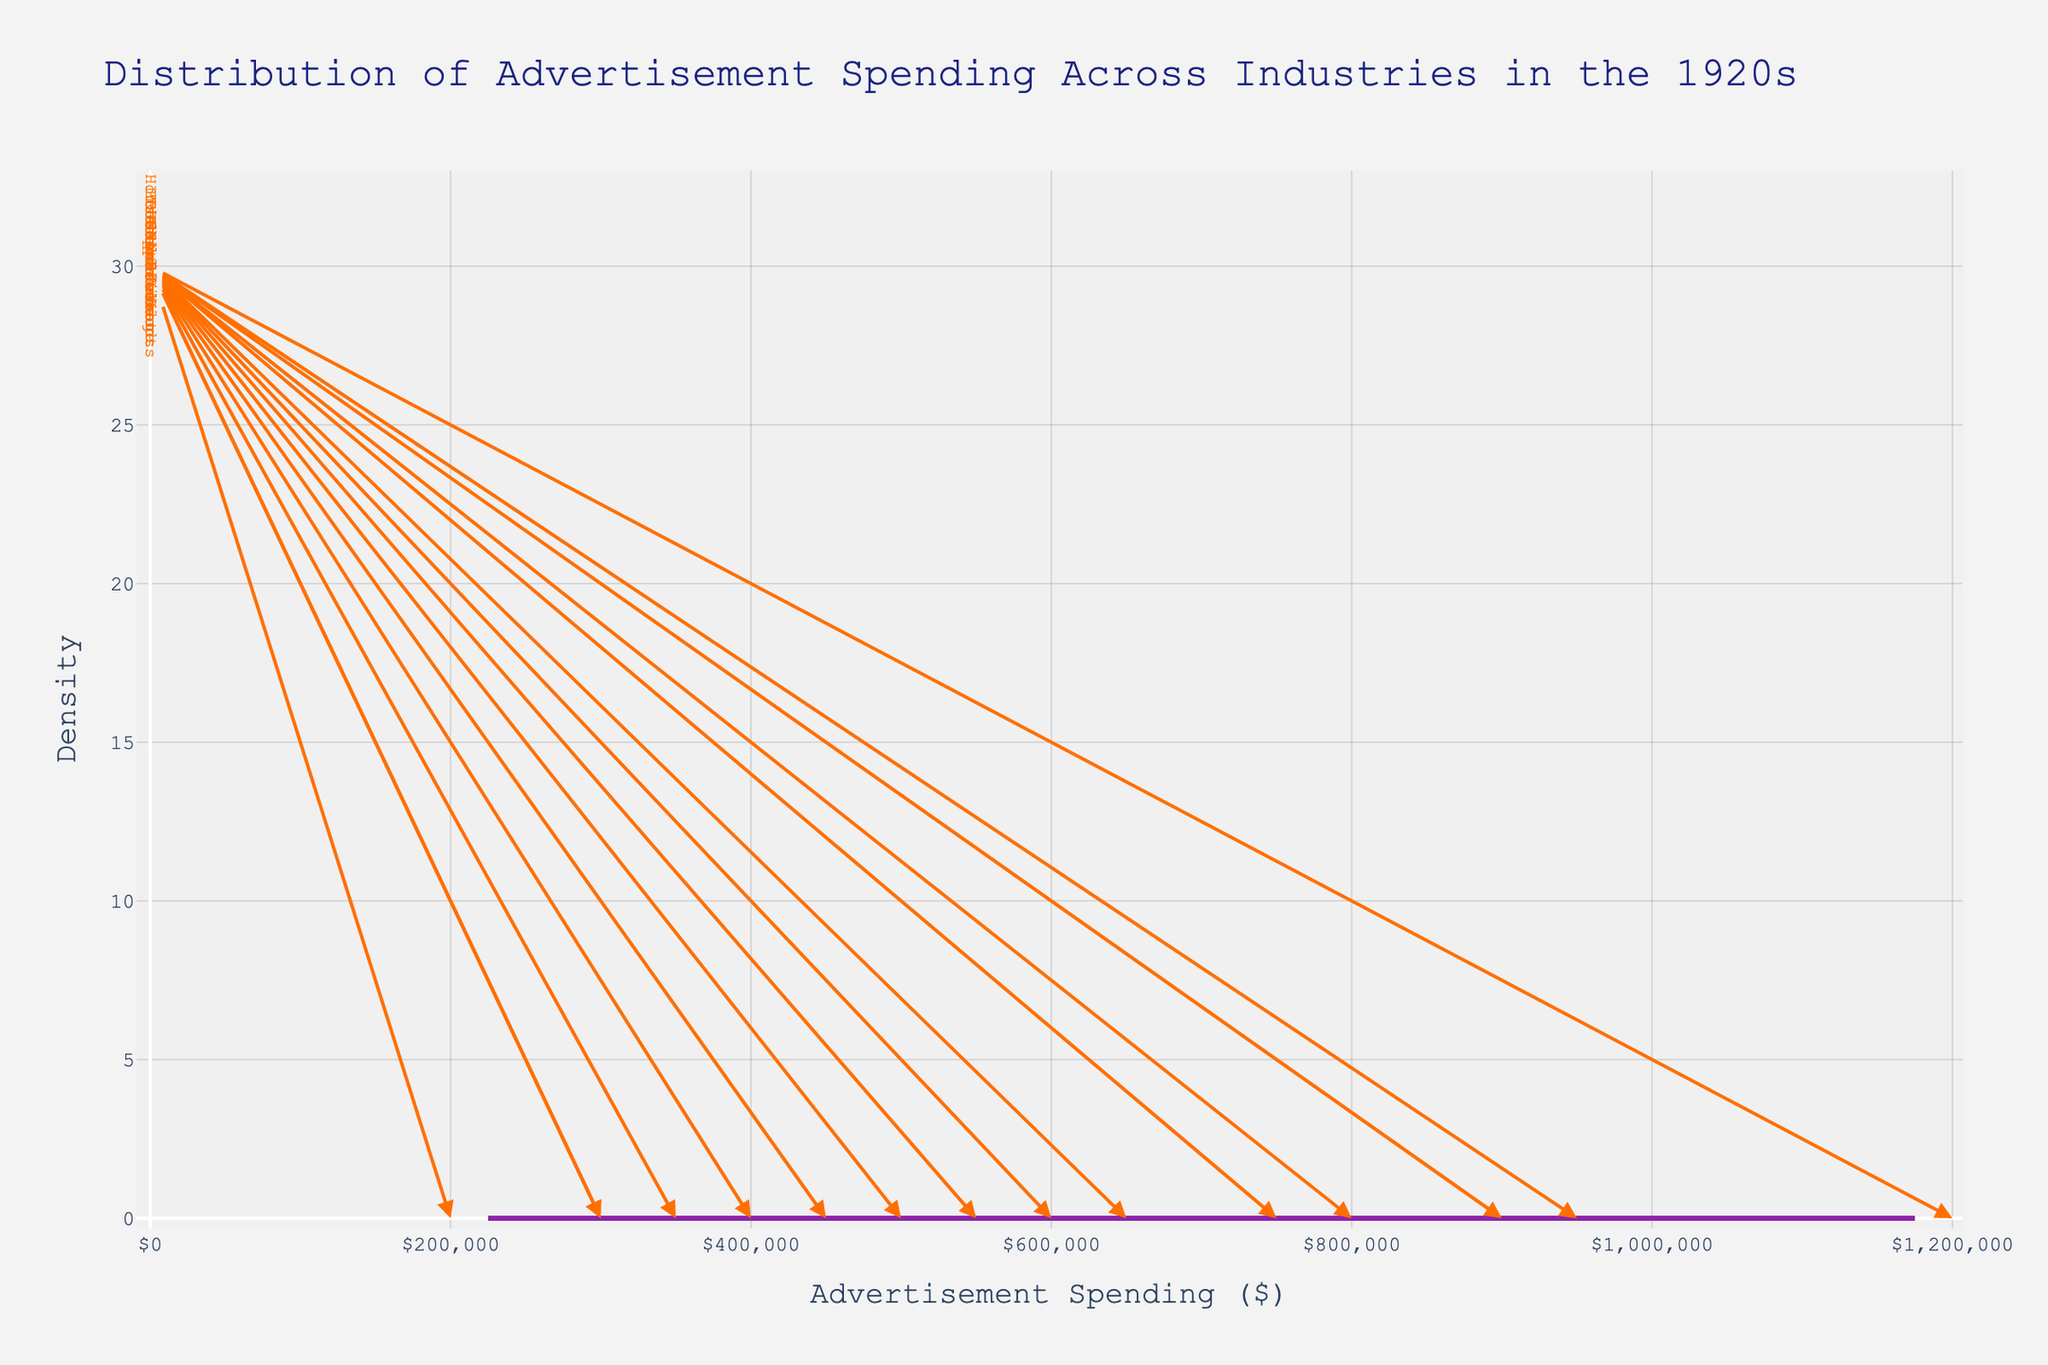What's the title of the plot? The title of the plot is located at the top of the graph and typically includes the main subject of the visualization.
Answer: Distribution of Advertisement Spending Across Industries in the 1920s What is the x-axis label? The x-axis label is shown below the horizontal axis and indicates what the x-values represent, which in this plot is the amount spent on advertising.
Answer: Advertisement Spending ($) What industry spent the largest amount on advertising? To determine which industry spent the most, look for the annotation at the highest x-value.
Answer: Automobile Which industry is closest to the median spending? The median is the middle value in the sorted list of amounts. To find it, observe which industries are around the center of the density peak.
Answer: Finance How many industries spent more than $750,000 on advertising? By identifying the industries that fall to the right of the $750,000 mark on the x-axis and counting them.
Answer: 5 industries Which spending amount witnessed the highest density? The highest density is the peak of the curve on the plot. Look for the x-value at this peak.
Answer: Around $600,000 Compare the spending of Healthcare and Cosmetics industries. Which one is higher? Find the annotations for Healthcare and Cosmetics and compare their positions on the x-axis.
Answer: Cosmetics What industry's spending is closest to $400,000? Identify the industry annotation that is marked nearest the $400,000 x-value on the plot.
Answer: Real Estate Is the density plot skewed, and if so, in which direction? Examine the shape of the density plot. If it stretches more to one side, it's skewed towards that direction.
Answer: It's skewed to the right Which two industries had the smallest ad expenditures, and what were the amounts? Locate the two smallest x-value annotations and read off the industries and their amounts.
Answer: Education ($200,000) and Household Products ($300,000) 